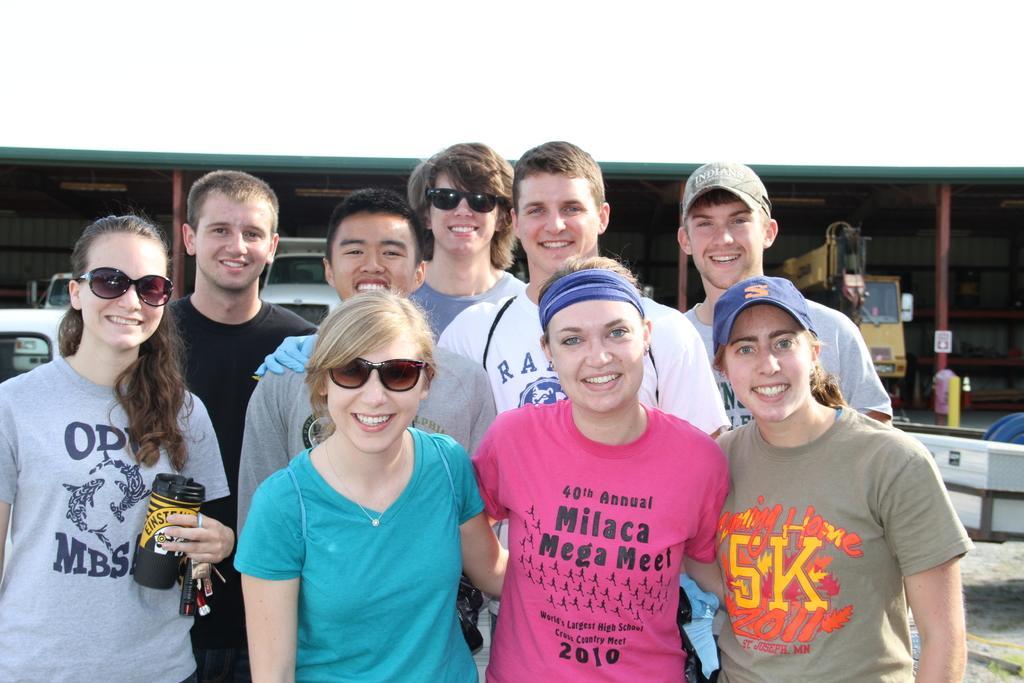Can you describe this image briefly? In the center of the image we can see some people are standing and smiling and some of them are wearing goggles, caps and a lady is holding a bottle. In the background of the image we can see a shed, poles, vehicles. In the bottom right corner we can see the ground. 